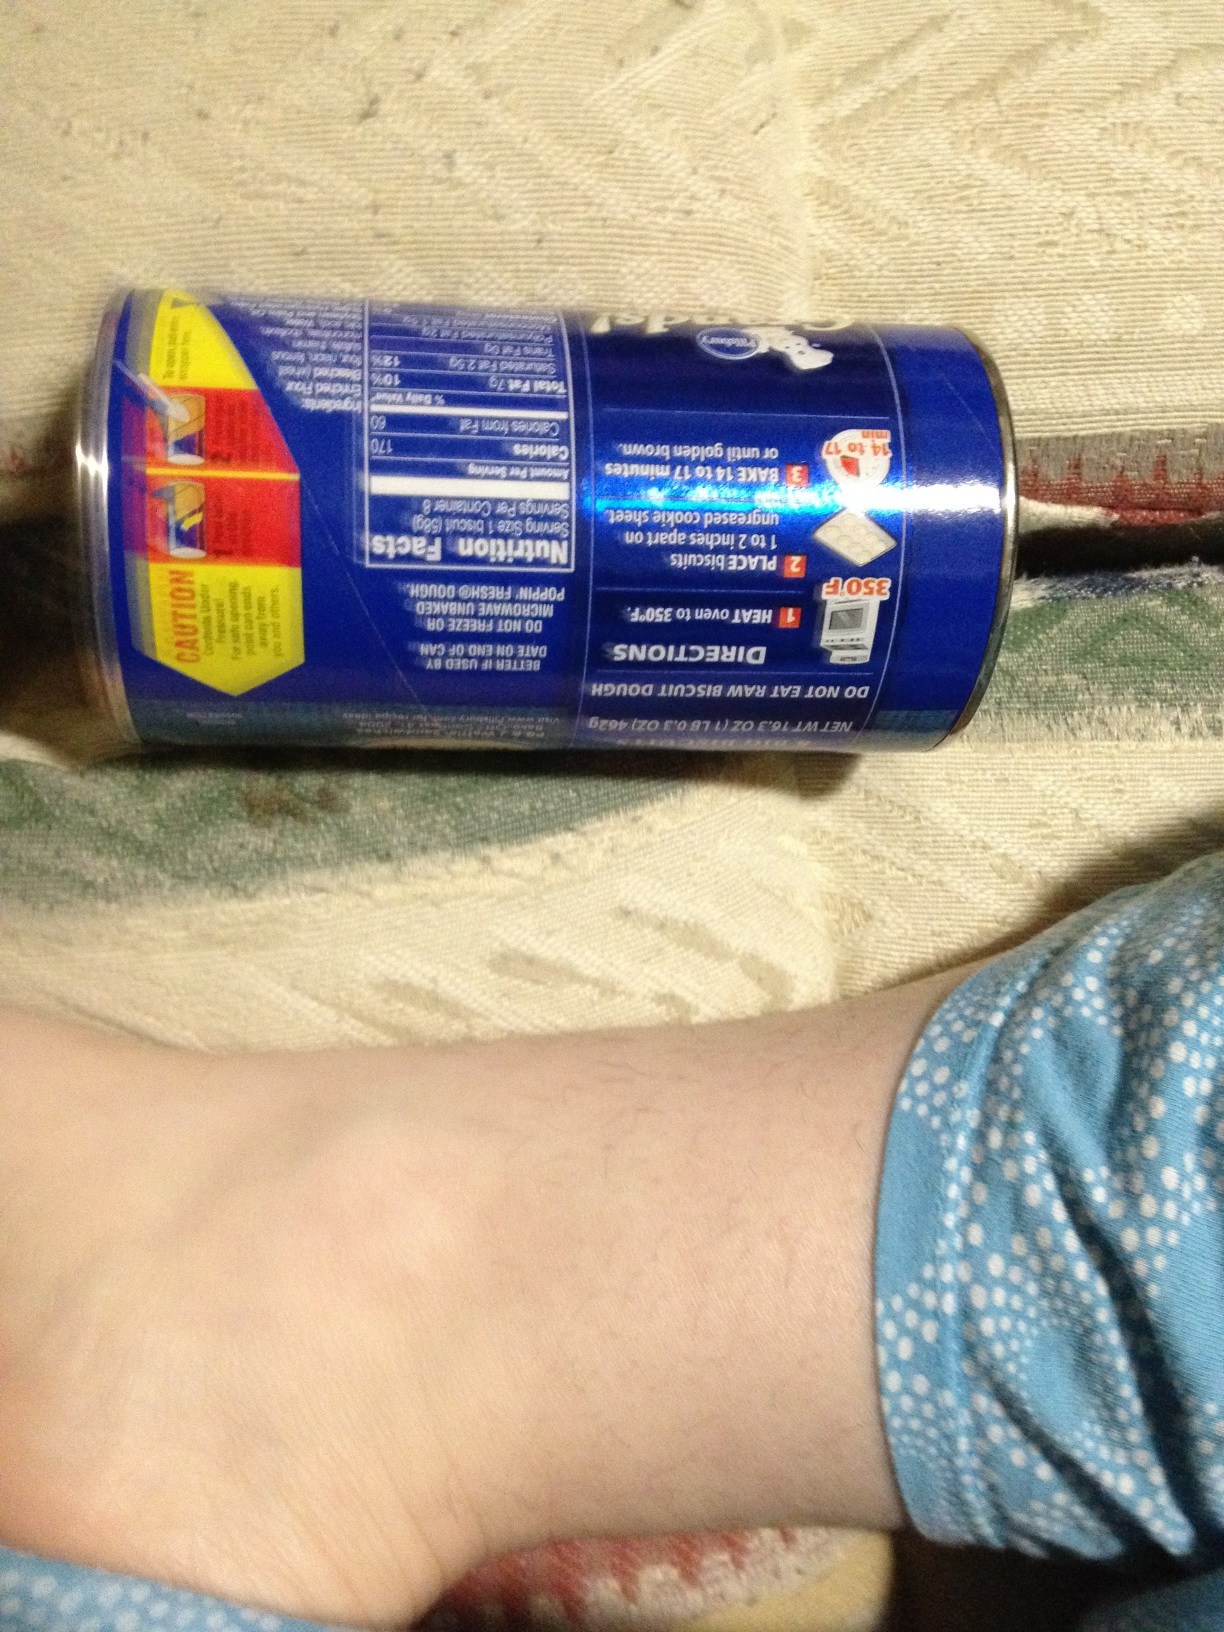What is the main theme or focus of the nutritional label visible in the image? The main focus of the nutritional label visible in the image is to provide the consumer with detailed information about the calorie content, fat, sodium, carbohydrates, protein per serving, and daily value percentages. Additionally, it includes cooking instructions and safety precautions to ensure proper usage and consumption of the product. 